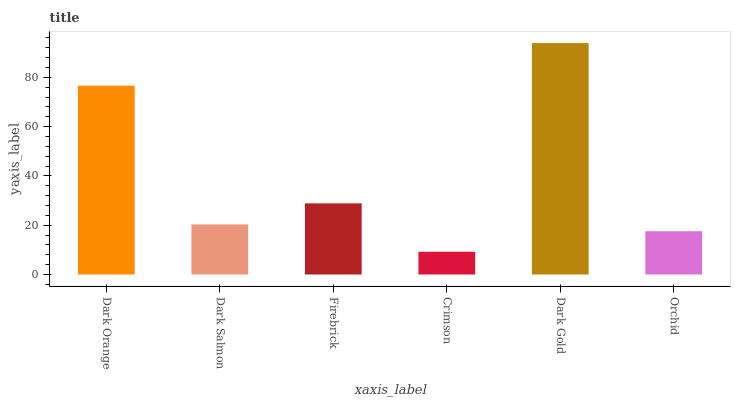Is Crimson the minimum?
Answer yes or no. Yes. Is Dark Gold the maximum?
Answer yes or no. Yes. Is Dark Salmon the minimum?
Answer yes or no. No. Is Dark Salmon the maximum?
Answer yes or no. No. Is Dark Orange greater than Dark Salmon?
Answer yes or no. Yes. Is Dark Salmon less than Dark Orange?
Answer yes or no. Yes. Is Dark Salmon greater than Dark Orange?
Answer yes or no. No. Is Dark Orange less than Dark Salmon?
Answer yes or no. No. Is Firebrick the high median?
Answer yes or no. Yes. Is Dark Salmon the low median?
Answer yes or no. Yes. Is Orchid the high median?
Answer yes or no. No. Is Orchid the low median?
Answer yes or no. No. 